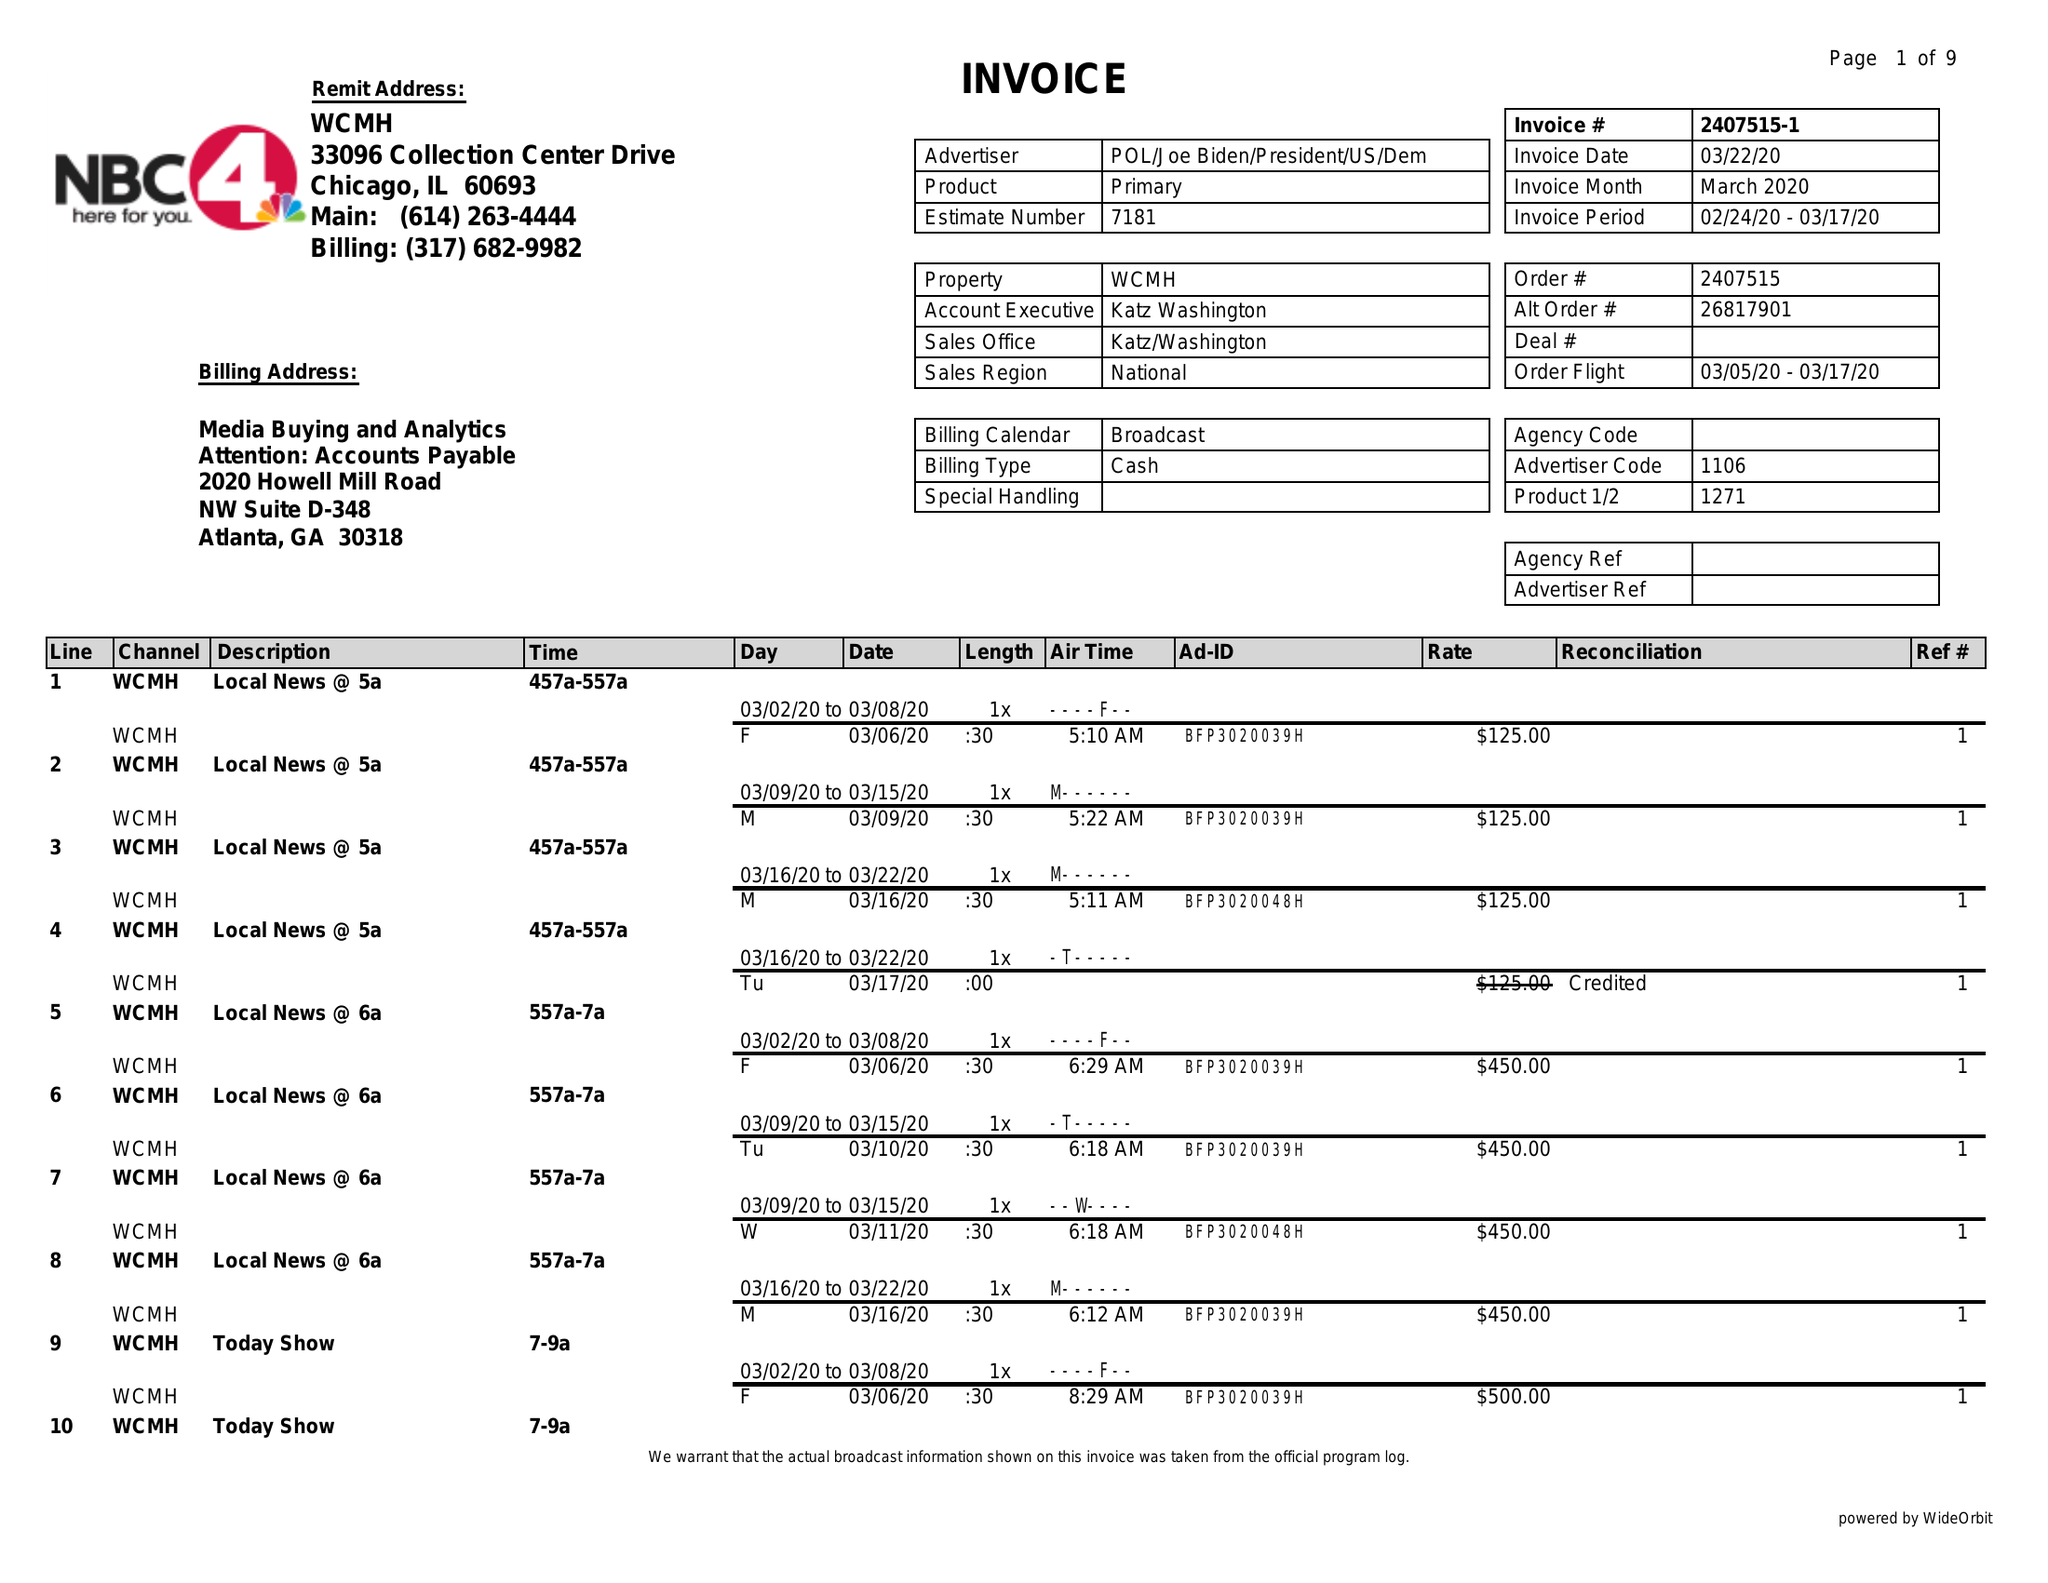What is the value for the flight_to?
Answer the question using a single word or phrase. 03/17/20 